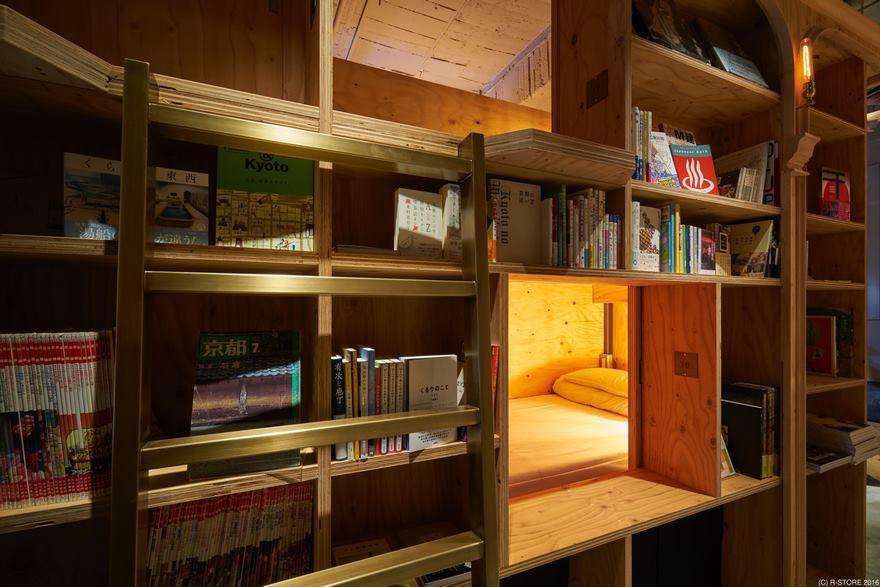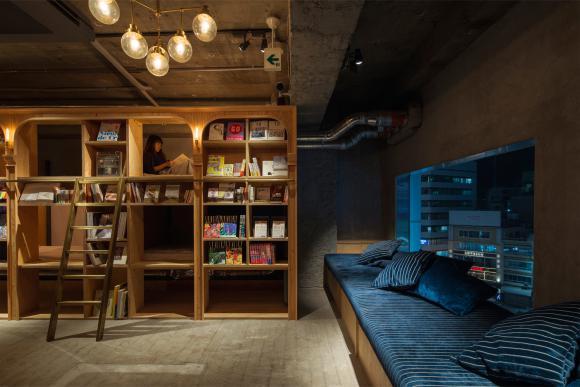The first image is the image on the left, the second image is the image on the right. Considering the images on both sides, is "In at least one image there is a blue couch facing left on the right with a person with dark hair sitting in the farthest cushing away." valid? Answer yes or no. No. The first image is the image on the left, the second image is the image on the right. Evaluate the accuracy of this statement regarding the images: "There is someone sitting on a blue cushion.". Is it true? Answer yes or no. No. 